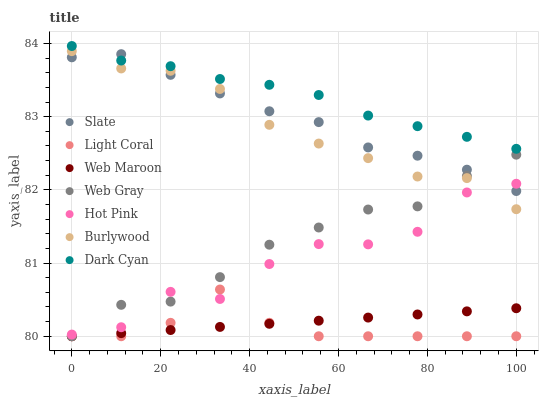Does Light Coral have the minimum area under the curve?
Answer yes or no. Yes. Does Dark Cyan have the maximum area under the curve?
Answer yes or no. Yes. Does Burlywood have the minimum area under the curve?
Answer yes or no. No. Does Burlywood have the maximum area under the curve?
Answer yes or no. No. Is Web Maroon the smoothest?
Answer yes or no. Yes. Is Hot Pink the roughest?
Answer yes or no. Yes. Is Burlywood the smoothest?
Answer yes or no. No. Is Burlywood the roughest?
Answer yes or no. No. Does Web Gray have the lowest value?
Answer yes or no. Yes. Does Burlywood have the lowest value?
Answer yes or no. No. Does Dark Cyan have the highest value?
Answer yes or no. Yes. Does Burlywood have the highest value?
Answer yes or no. No. Is Web Maroon less than Burlywood?
Answer yes or no. Yes. Is Slate greater than Light Coral?
Answer yes or no. Yes. Does Light Coral intersect Web Gray?
Answer yes or no. Yes. Is Light Coral less than Web Gray?
Answer yes or no. No. Is Light Coral greater than Web Gray?
Answer yes or no. No. Does Web Maroon intersect Burlywood?
Answer yes or no. No. 